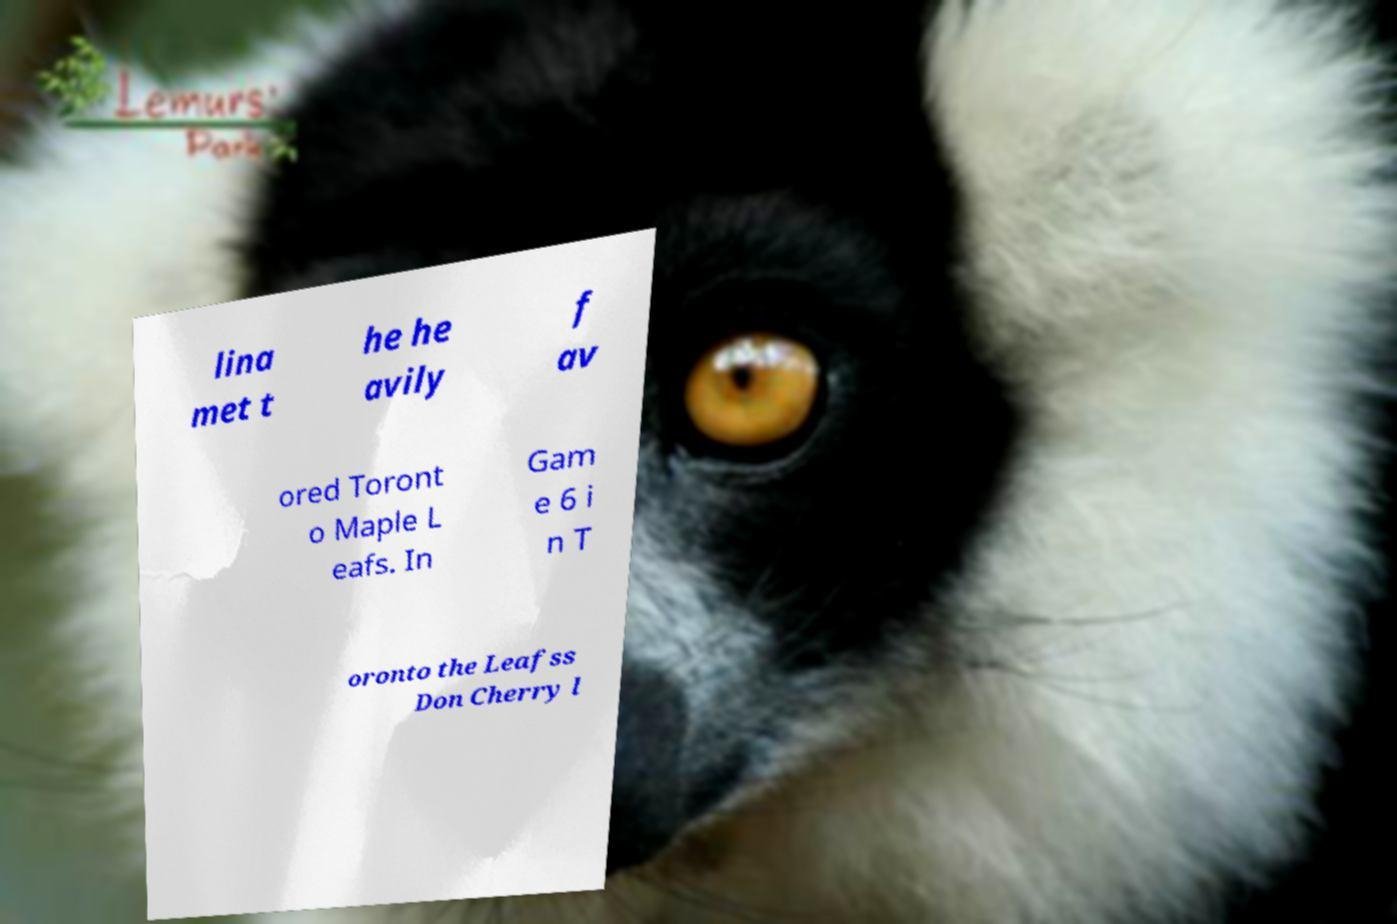Please read and relay the text visible in this image. What does it say? lina met t he he avily f av ored Toront o Maple L eafs. In Gam e 6 i n T oronto the Leafss Don Cherry l 